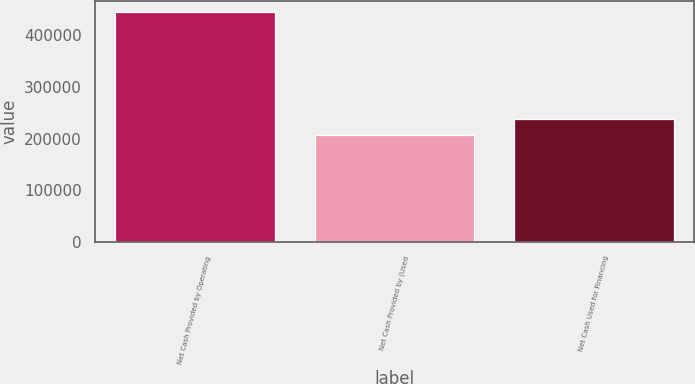Convert chart to OTSL. <chart><loc_0><loc_0><loc_500><loc_500><bar_chart><fcel>Net Cash Provided by Operating<fcel>Net Cash Provided by (Used<fcel>Net Cash Used for Financing<nl><fcel>444487<fcel>207031<fcel>238809<nl></chart> 